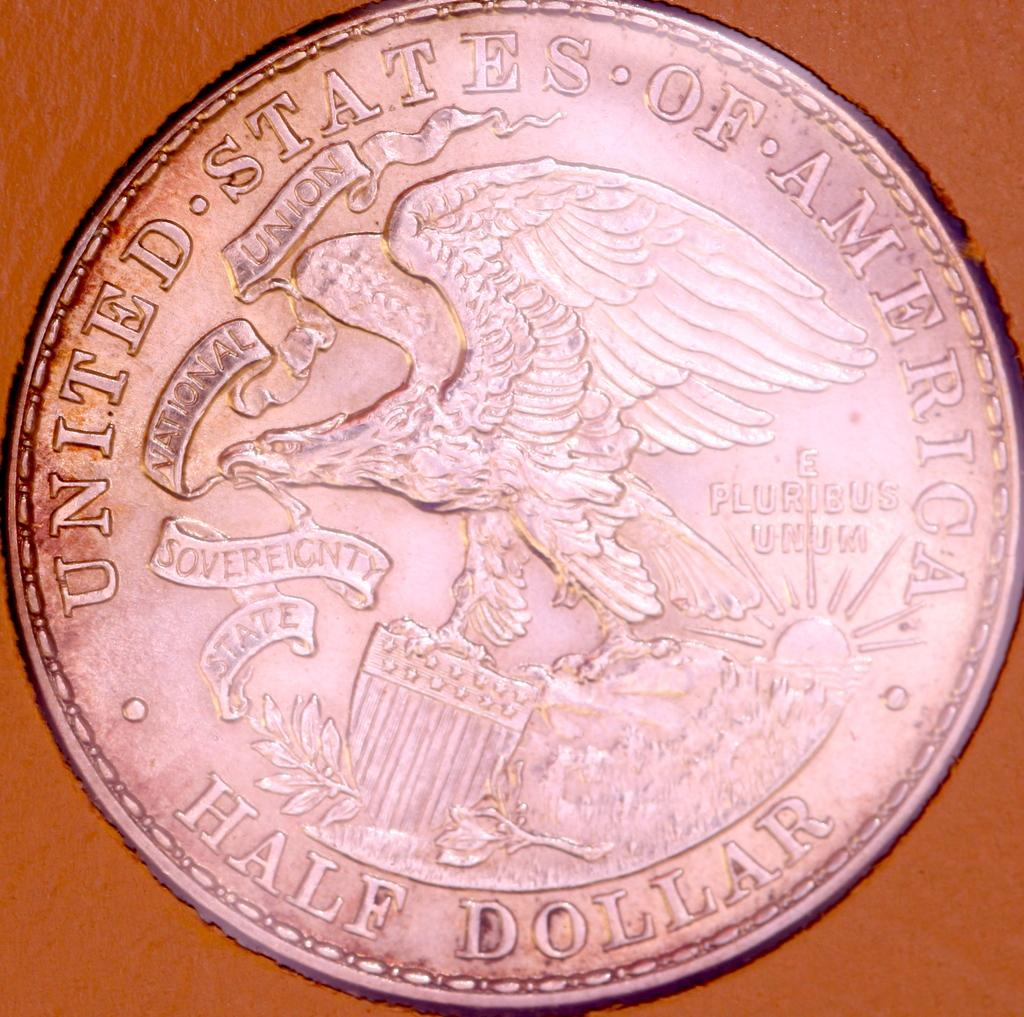<image>
Offer a succinct explanation of the picture presented. The silver coin on the table is labeled half dollar 